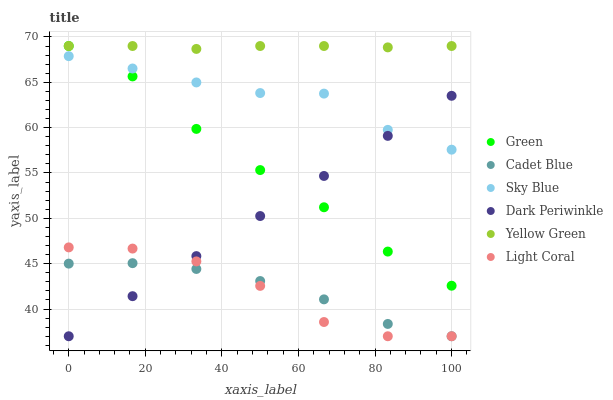Does Light Coral have the minimum area under the curve?
Answer yes or no. Yes. Does Yellow Green have the maximum area under the curve?
Answer yes or no. Yes. Does Yellow Green have the minimum area under the curve?
Answer yes or no. No. Does Light Coral have the maximum area under the curve?
Answer yes or no. No. Is Dark Periwinkle the smoothest?
Answer yes or no. Yes. Is Light Coral the roughest?
Answer yes or no. Yes. Is Yellow Green the smoothest?
Answer yes or no. No. Is Yellow Green the roughest?
Answer yes or no. No. Does Cadet Blue have the lowest value?
Answer yes or no. Yes. Does Yellow Green have the lowest value?
Answer yes or no. No. Does Green have the highest value?
Answer yes or no. Yes. Does Light Coral have the highest value?
Answer yes or no. No. Is Cadet Blue less than Yellow Green?
Answer yes or no. Yes. Is Yellow Green greater than Cadet Blue?
Answer yes or no. Yes. Does Dark Periwinkle intersect Sky Blue?
Answer yes or no. Yes. Is Dark Periwinkle less than Sky Blue?
Answer yes or no. No. Is Dark Periwinkle greater than Sky Blue?
Answer yes or no. No. Does Cadet Blue intersect Yellow Green?
Answer yes or no. No. 